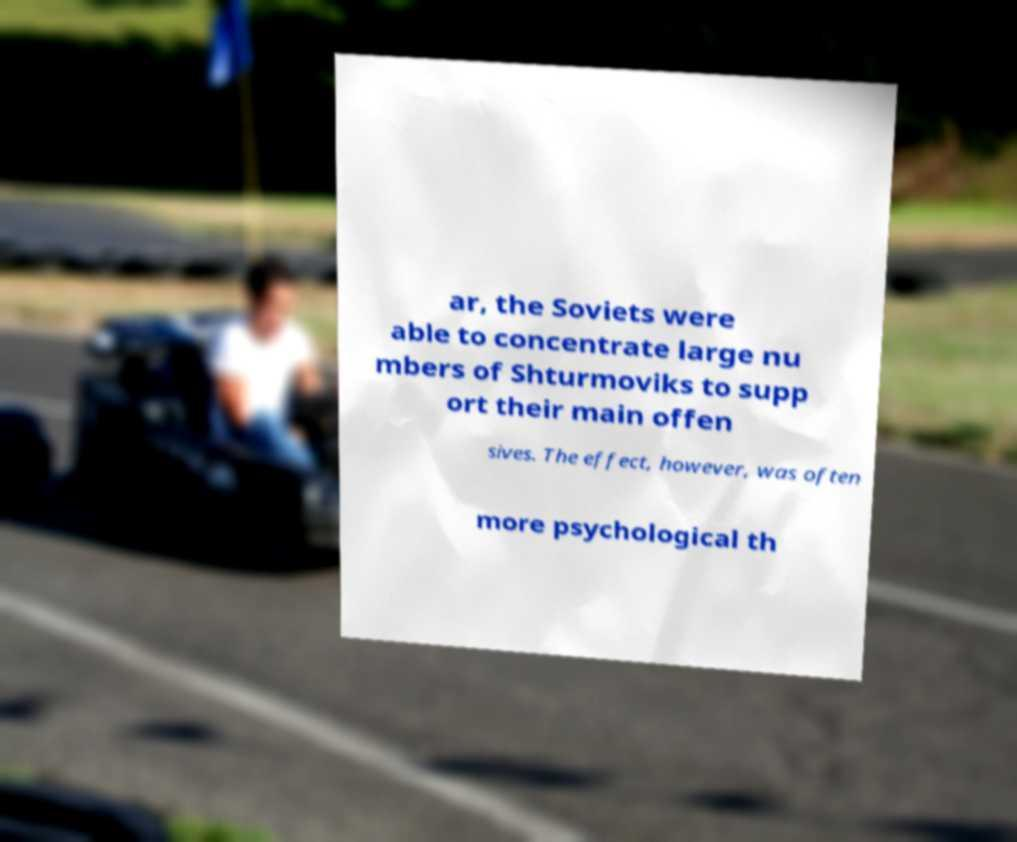Can you read and provide the text displayed in the image?This photo seems to have some interesting text. Can you extract and type it out for me? ar, the Soviets were able to concentrate large nu mbers of Shturmoviks to supp ort their main offen sives. The effect, however, was often more psychological th 